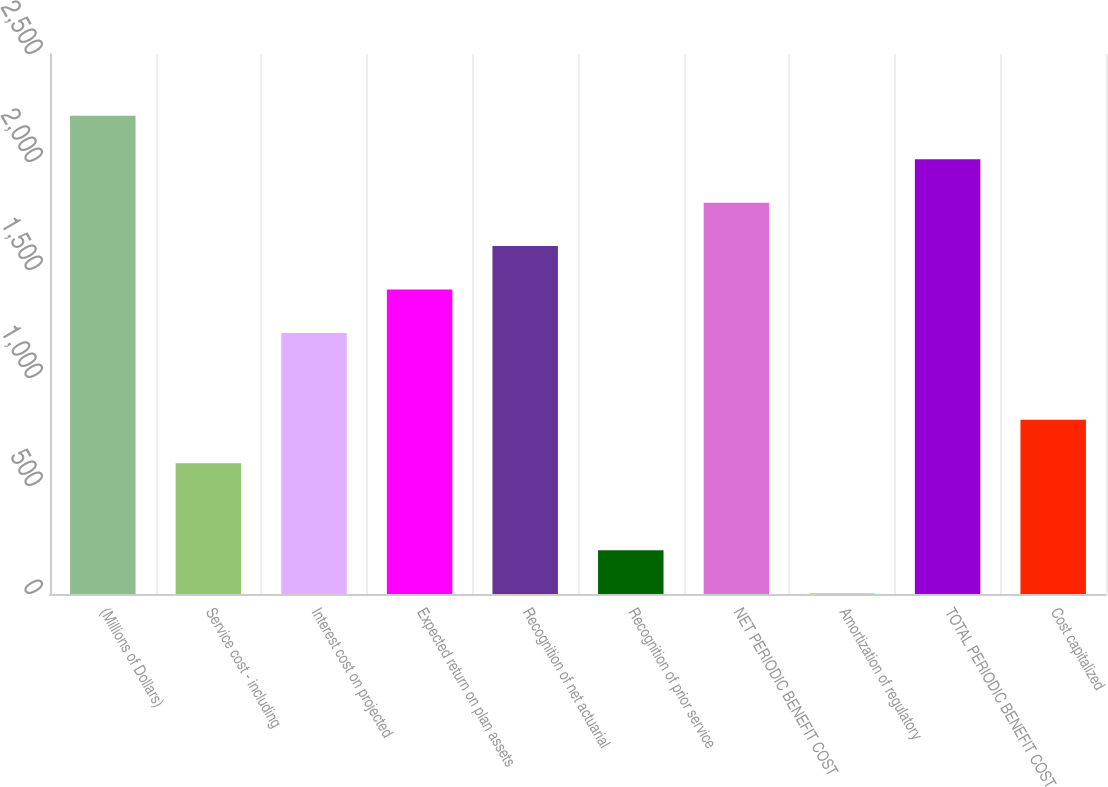Convert chart to OTSL. <chart><loc_0><loc_0><loc_500><loc_500><bar_chart><fcel>(Millions of Dollars)<fcel>Service cost - including<fcel>Interest cost on projected<fcel>Expected return on plan assets<fcel>Recognition of net actuarial<fcel>Recognition of prior service<fcel>NET PERIODIC BENEFIT COST<fcel>Amortization of regulatory<fcel>TOTAL PERIODIC BENEFIT COST<fcel>Cost capitalized<nl><fcel>2214.1<fcel>605.3<fcel>1208.6<fcel>1409.7<fcel>1610.8<fcel>203.1<fcel>1811.9<fcel>2<fcel>2013<fcel>806.4<nl></chart> 